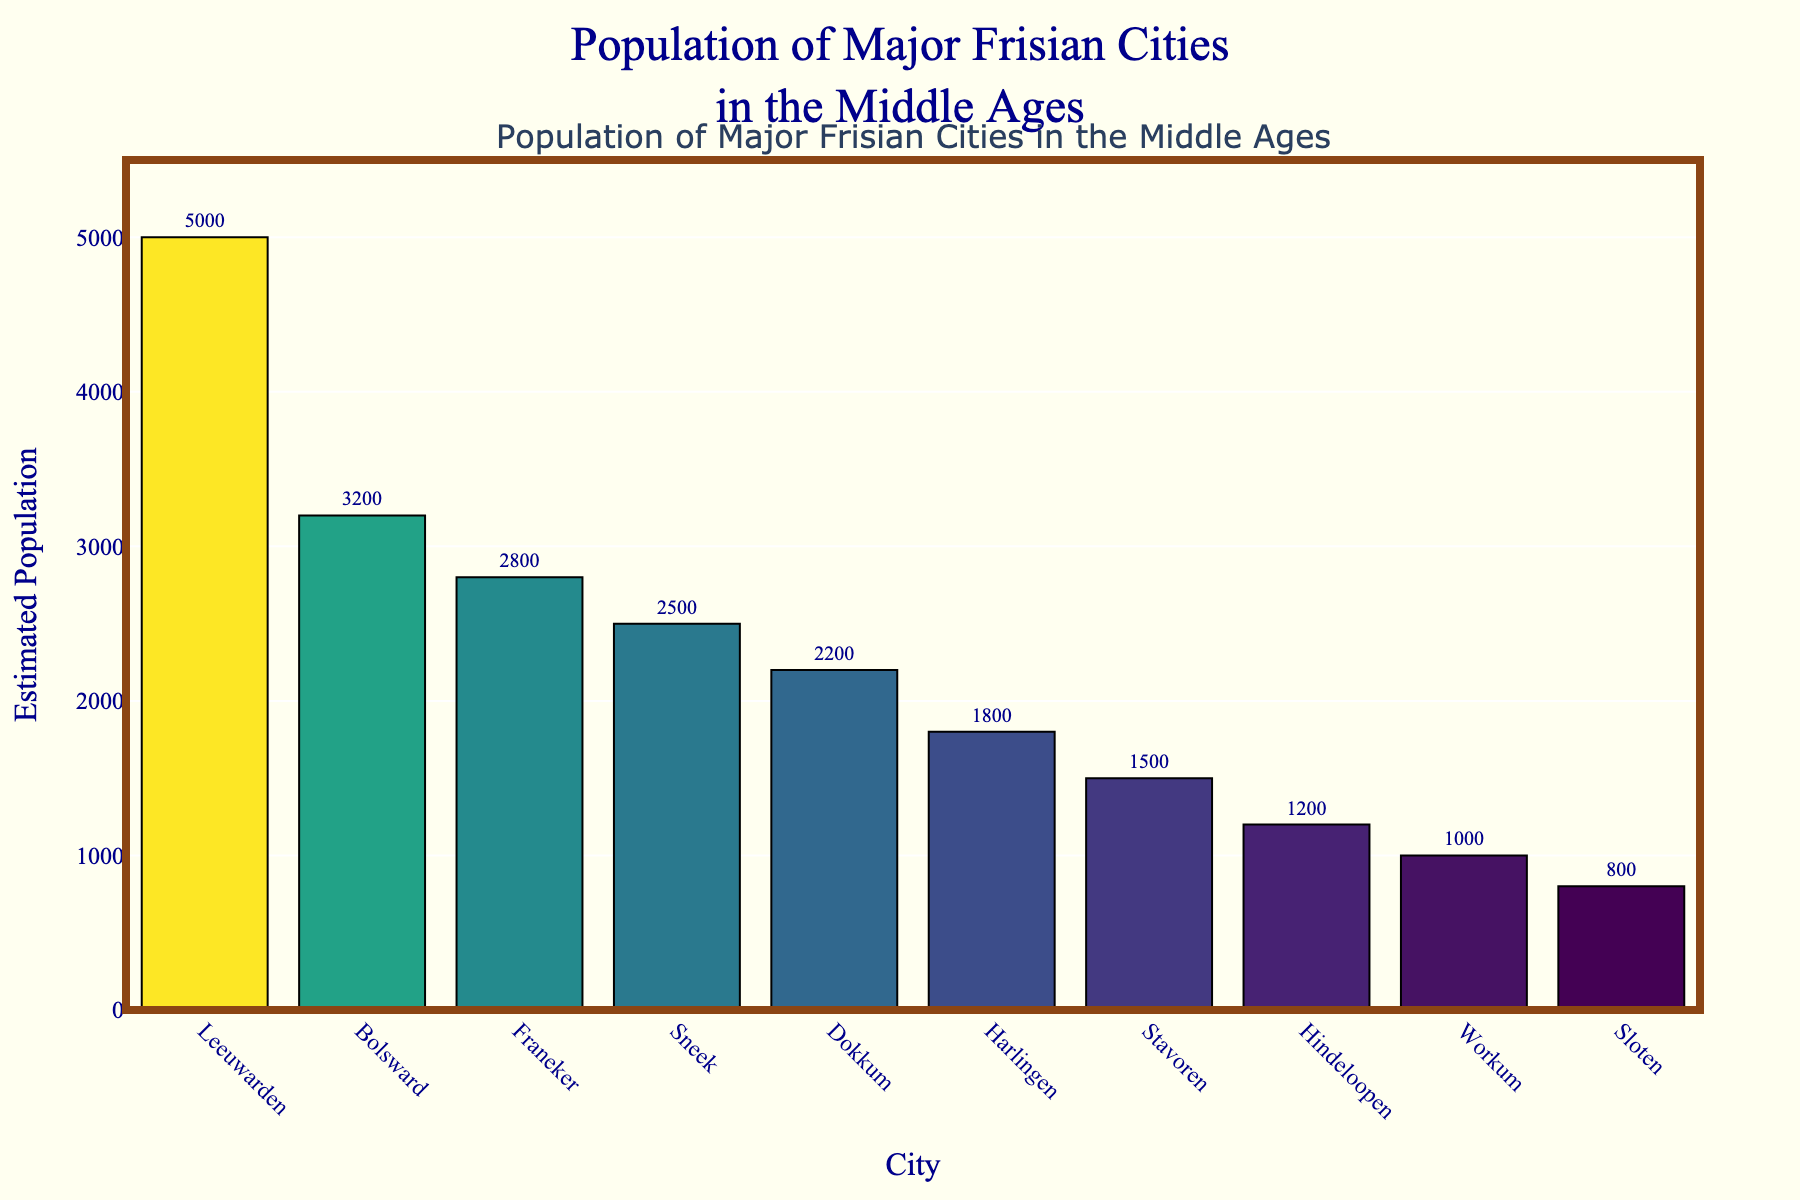Which city had the highest estimated population during the Middle Ages? The bar representing Leeuwarden is the tallest, indicating that it had the highest estimated population.
Answer: Leeuwarden What is the total estimated population of Sneek and Harlingen combined? The estimated population of Sneek is 2,500 and Harlingen is 1,800. Adding them together gives 2,500 + 1,800.
Answer: 4,300 Is Dokkum's estimated population greater than Franeker's? Dokkum has an estimated population of 2,200, which is less than Franeker's population of 2,800.
Answer: No How much larger is Bolsward's population compared to Workum's? Bolsward has an estimated population of 3,200, and Workum has 1,000. Subtracting Workum's population from Bolsward’s gives 3,200 - 1,000.
Answer: 2,200 Which three cities have the smallest estimated populations? The three shortest bars represent Hindeloopen, Workum, and Sloten with populations of 1,200, 1,000, and 800 respectively.
Answer: Hindeloopen, Workum, Sloten What is the average estimated population of Leeuwarden, Bolsward, and Franeker? Adding the populations of Leeuwarden (5,000), Bolsward (3,200), and Franeker (2,800) gives 5,000 + 3,200 + 2,800 = 11,000. Dividing by 3 gives 11,000 / 3.
Answer: 3,667 Which city has an estimated population of 1,800? The bar labeled Harlingen represents an estimated population of 1,800.
Answer: Harlingen How does the population of Stavoren compare to Dokkum? Stavoren has an estimated population of 1,500 and Dokkum has 2,200. Therefore, Stavoren's population is less.
Answer: Less What is the total estimated population of all the cities combined? Adding the populations of all cities (5,000 + 3,200 + 2,800 + 2,500 + 2,200 + 1,800 + 1,500 + 1,200 + 1,000 + 800) gives a sum total.
Answer: 22,000 Is Sneek's estimated population closer to Bolsward or Franeker? The population of Sneek is 2,500. Comparing the differences: 3,200 - 2,500 = 700 for Bolsward and 2,800 - 2,500 = 300 for Franeker. Sneek's population is closer to Franeker.
Answer: Franeker 